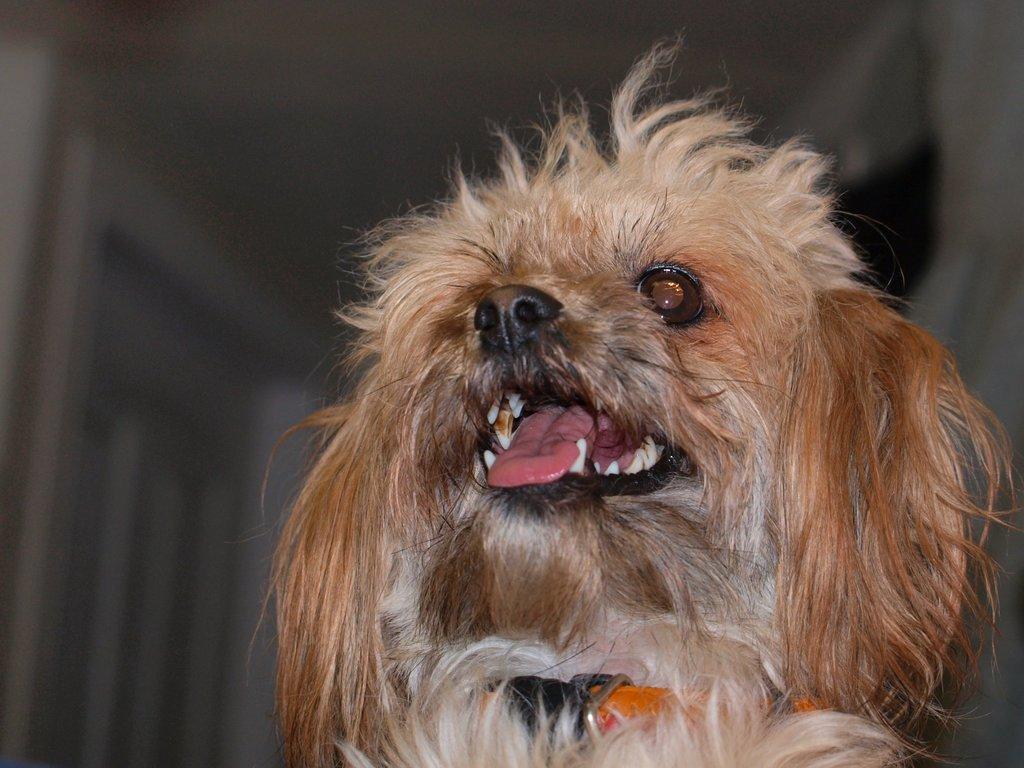Can you describe this image briefly? In this image I can see a cream colour dog in the front and around the dog's neck I can see an orange colour belt. I can also see this image is blurry in the background. 